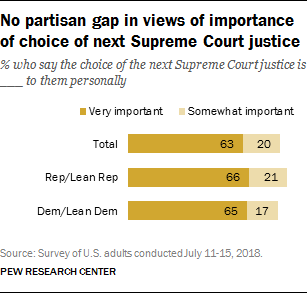Give some essential details in this illustration. The value of all three pink bars in the graph is 58. The color of the Very Important bar in the graph is orange. 